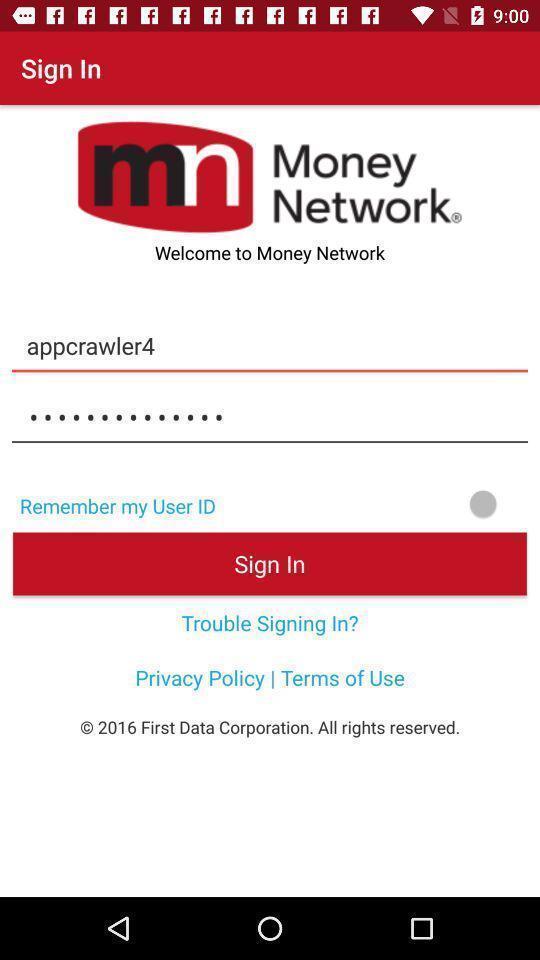What is the overall content of this screenshot? Welcome to the sign in page. 